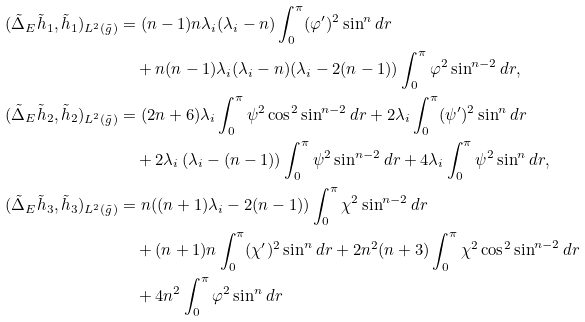<formula> <loc_0><loc_0><loc_500><loc_500>( \tilde { \Delta } _ { E } \tilde { h } _ { 1 } , \tilde { h } _ { 1 } ) _ { L ^ { 2 } ( \tilde { g } ) } & = ( n - 1 ) n \lambda _ { i } ( \lambda _ { i } - n ) \int _ { 0 } ^ { \pi } ( \varphi ^ { \prime } ) ^ { 2 } \sin ^ { n } d r \\ & \quad + n ( n - 1 ) \lambda _ { i } ( \lambda _ { i } - n ) ( \lambda _ { i } - 2 ( n - 1 ) ) \int _ { 0 } ^ { \pi } \varphi ^ { 2 } \sin ^ { n - 2 } d r , \\ ( \tilde { \Delta } _ { E } \tilde { h } _ { 2 } , \tilde { h } _ { 2 } ) _ { L ^ { 2 } ( \tilde { g } ) } & = ( 2 n + 6 ) \lambda _ { i } \int _ { 0 } ^ { \pi } \psi ^ { 2 } \cos ^ { 2 } \sin ^ { n - 2 } d r + 2 \lambda _ { i } \int _ { 0 } ^ { \pi } ( \psi ^ { \prime } ) ^ { 2 } \sin ^ { n } d r \\ & \quad + 2 \lambda _ { i } \left ( \lambda _ { i } - ( n - 1 ) \right ) \int _ { 0 } ^ { \pi } \psi ^ { 2 } \sin ^ { n - 2 } d r + 4 \lambda _ { i } \int _ { 0 } ^ { \pi } \psi ^ { 2 } \sin ^ { n } d r , \\ ( \tilde { \Delta } _ { E } \tilde { h } _ { 3 } , \tilde { h } _ { 3 } ) _ { L ^ { 2 } ( \tilde { g } ) } & = n ( ( n + 1 ) \lambda _ { i } - 2 ( n - 1 ) ) \int _ { 0 } ^ { \pi } \chi ^ { 2 } \sin ^ { n - 2 } d r \\ & \quad + ( n + 1 ) n \int _ { 0 } ^ { \pi } ( \chi ^ { \prime } ) ^ { 2 } \sin ^ { n } d r + 2 n ^ { 2 } ( n + 3 ) \int _ { 0 } ^ { \pi } \chi ^ { 2 } \cos ^ { 2 } \sin ^ { n - 2 } d r \\ & \quad + 4 n ^ { 2 } \int _ { 0 } ^ { \pi } \varphi ^ { 2 } \sin ^ { n } d r</formula> 